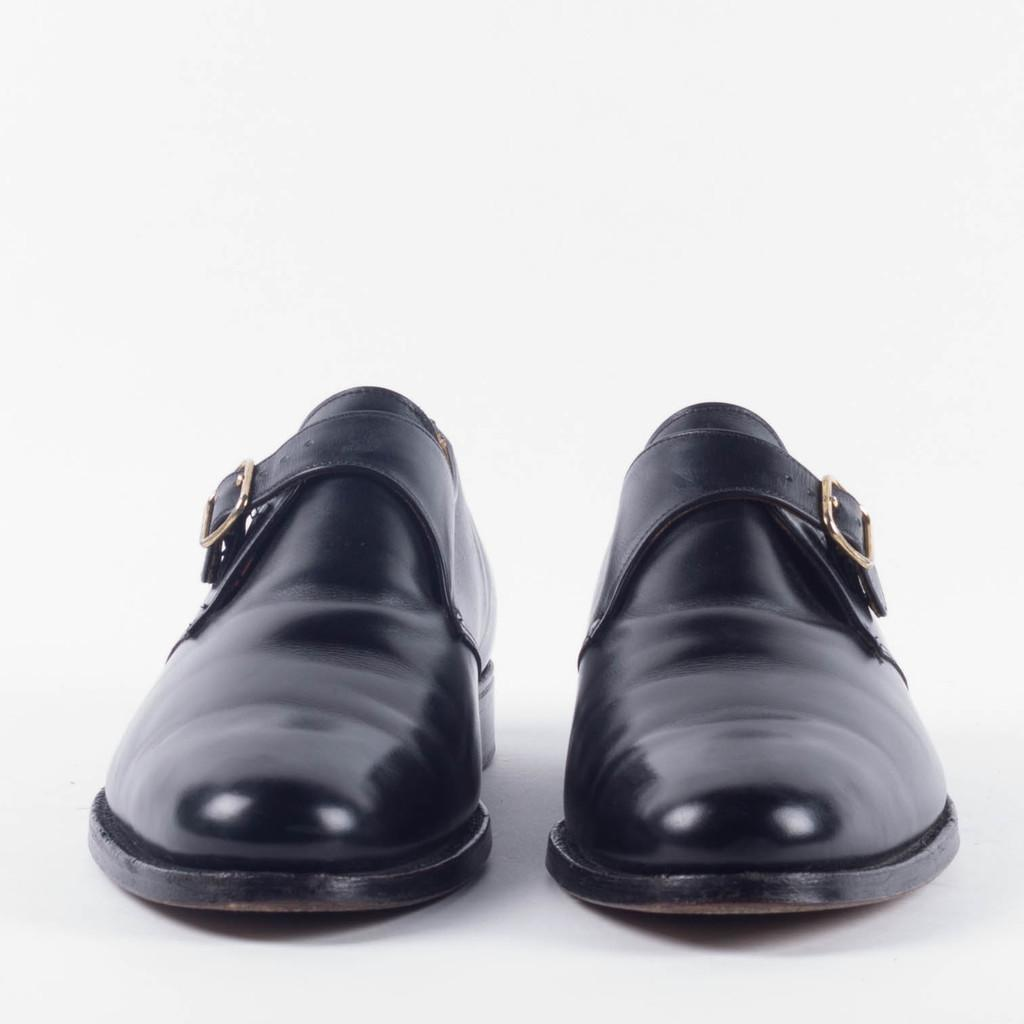What color are the shoes in the image? The shoes in the image are black-colored. Where are the shoes located in the image? The shoes are present on the floor. What type of drug is visible in the image? There is no drug present in the image; it only features black-colored shoes on the floor. 